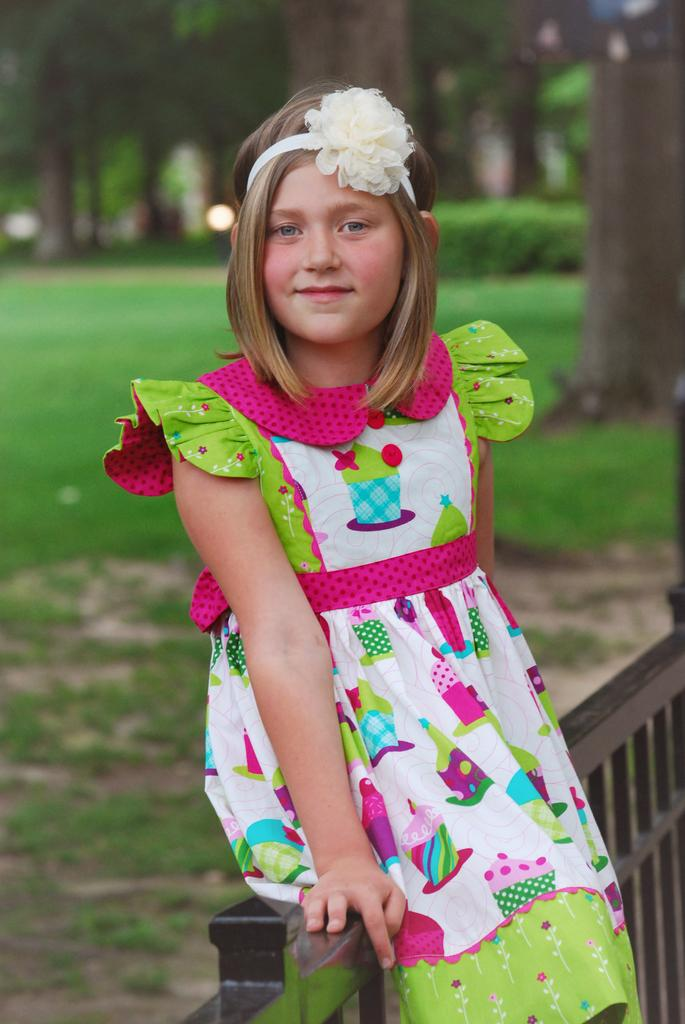Who is the main subject in the image? There is a girl in the image. What is the girl doing in the image? The girl is seated on a metal fence. What is the girl's facial expression in the image? The girl is smiling. What is the girl wearing on her head in the image? The girl has a hair band on her head. What type of vegetation can be seen in the image? There are trees visible in the image. What is the ground covered with in the image? There is grass on the ground in the image. What flavor of soda is the girl holding in the image? There is no soda present in the image; the girl is seated on a metal fence and smiling. 